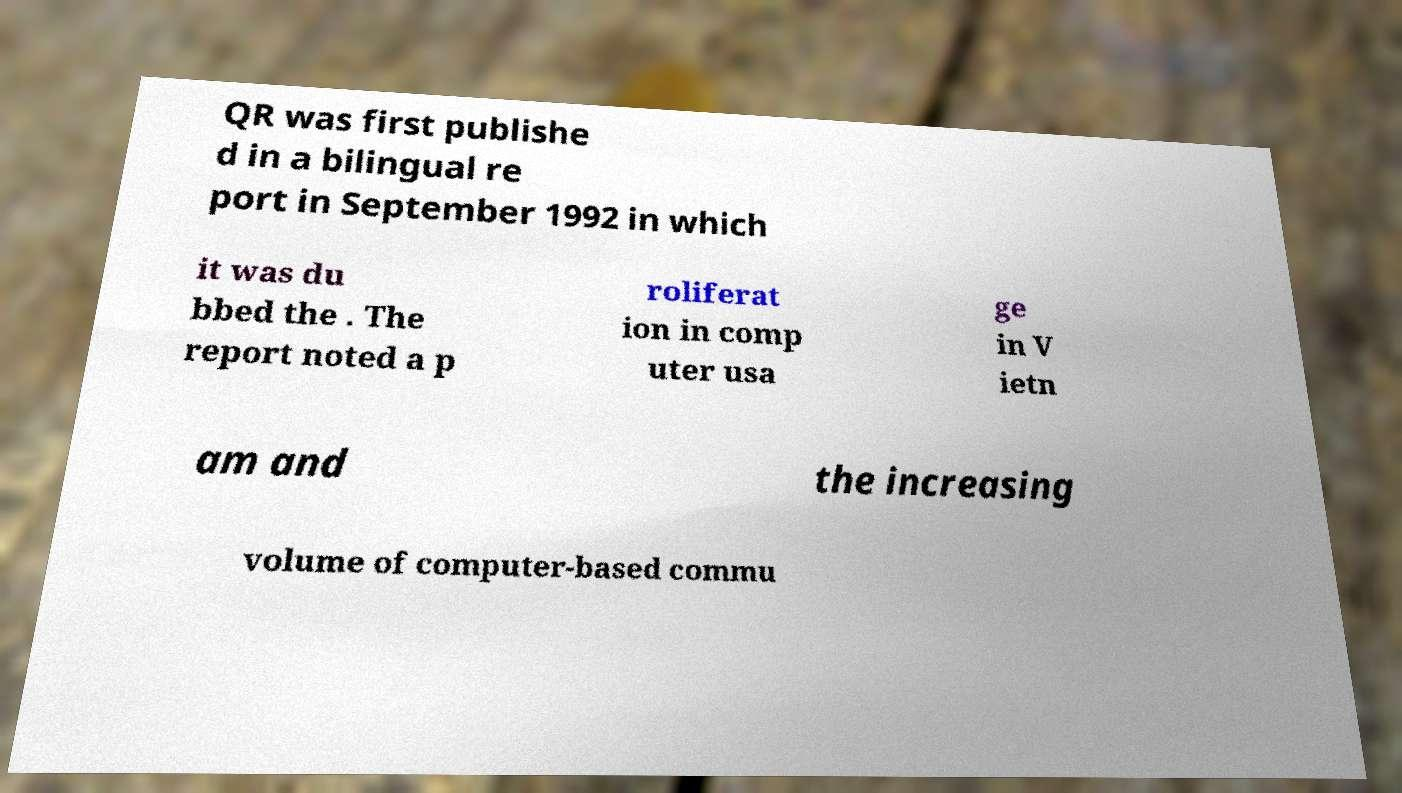Can you read and provide the text displayed in the image?This photo seems to have some interesting text. Can you extract and type it out for me? QR was first publishe d in a bilingual re port in September 1992 in which it was du bbed the . The report noted a p roliferat ion in comp uter usa ge in V ietn am and the increasing volume of computer-based commu 